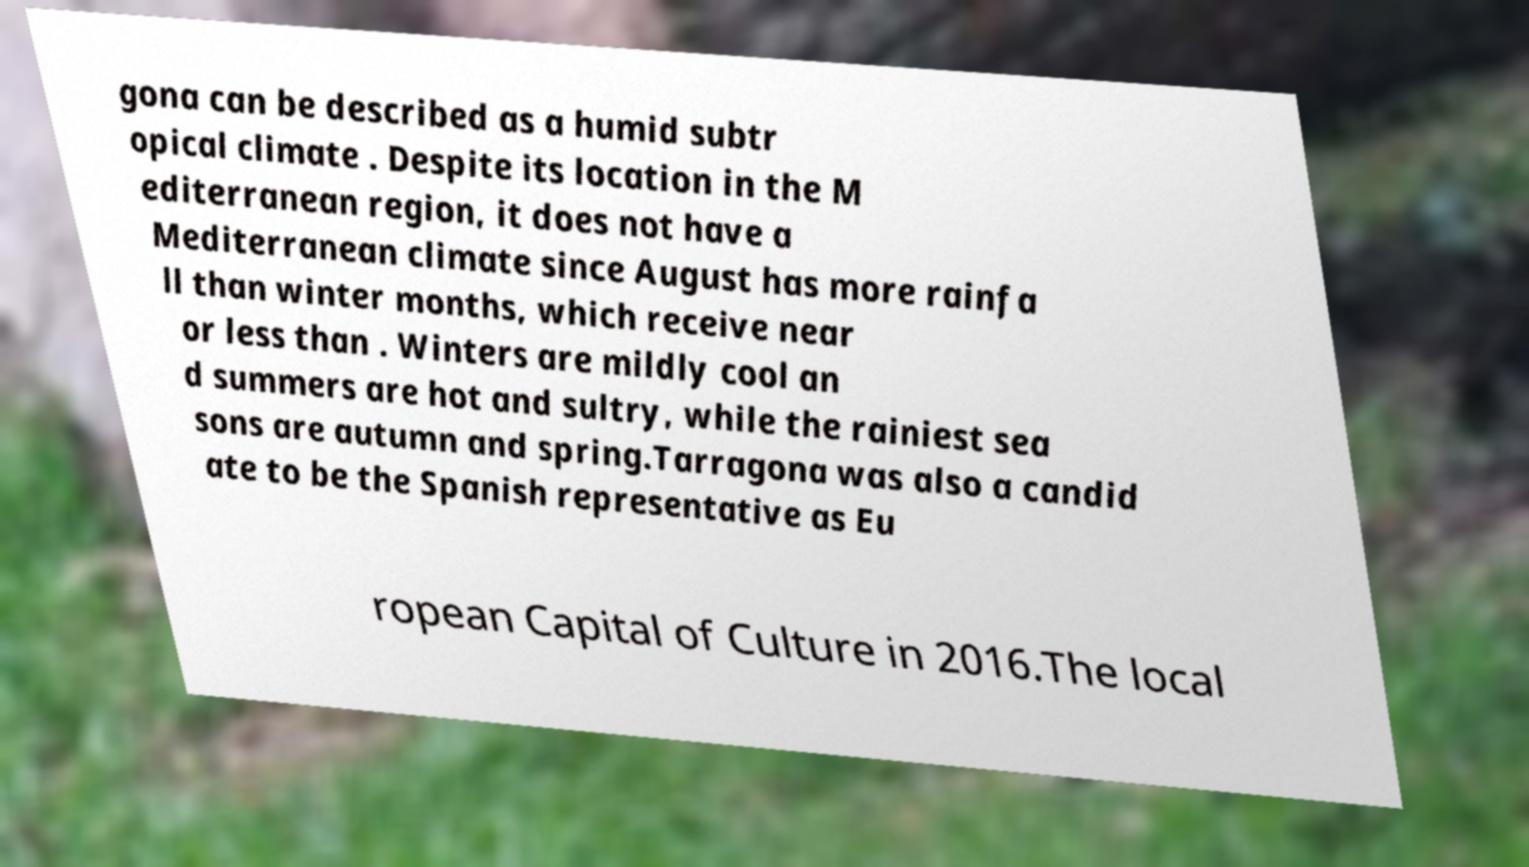There's text embedded in this image that I need extracted. Can you transcribe it verbatim? gona can be described as a humid subtr opical climate . Despite its location in the M editerranean region, it does not have a Mediterranean climate since August has more rainfa ll than winter months, which receive near or less than . Winters are mildly cool an d summers are hot and sultry, while the rainiest sea sons are autumn and spring.Tarragona was also a candid ate to be the Spanish representative as Eu ropean Capital of Culture in 2016.The local 